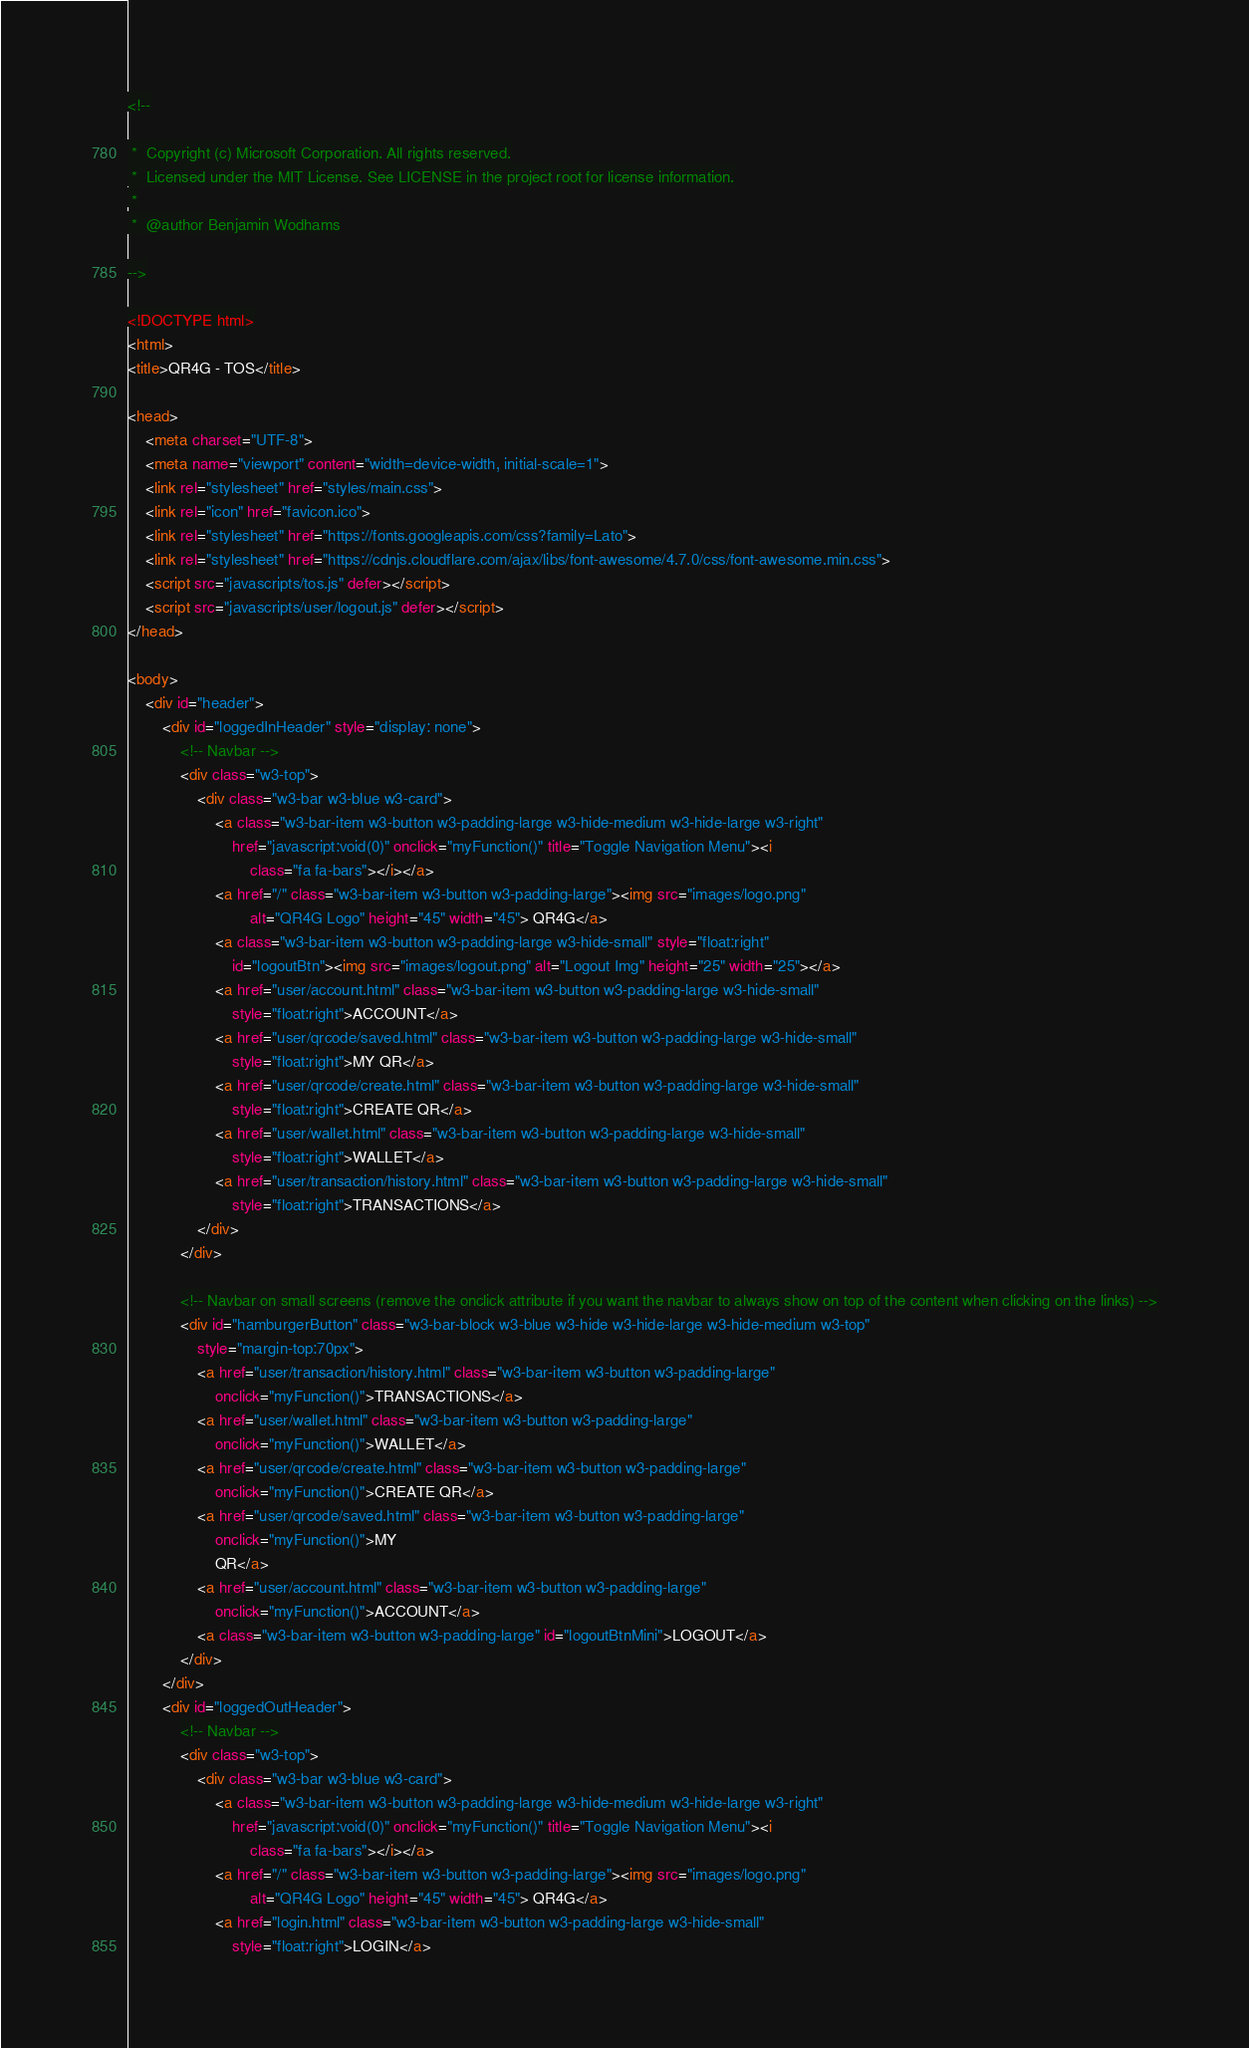Convert code to text. <code><loc_0><loc_0><loc_500><loc_500><_HTML_><!--

 *  Copyright (c) Microsoft Corporation. All rights reserved.
 *  Licensed under the MIT License. See LICENSE in the project root for license information.
 *
 *  @author Benjamin Wodhams

-->

<!DOCTYPE html>
<html>
<title>QR4G - TOS</title>

<head>
    <meta charset="UTF-8">
    <meta name="viewport" content="width=device-width, initial-scale=1">
    <link rel="stylesheet" href="styles/main.css">
    <link rel="icon" href="favicon.ico">
    <link rel="stylesheet" href="https://fonts.googleapis.com/css?family=Lato">
    <link rel="stylesheet" href="https://cdnjs.cloudflare.com/ajax/libs/font-awesome/4.7.0/css/font-awesome.min.css">
    <script src="javascripts/tos.js" defer></script>
    <script src="javascripts/user/logout.js" defer></script>
</head>

<body>
    <div id="header">
        <div id="loggedInHeader" style="display: none">
            <!-- Navbar -->
            <div class="w3-top">
                <div class="w3-bar w3-blue w3-card">
                    <a class="w3-bar-item w3-button w3-padding-large w3-hide-medium w3-hide-large w3-right"
                        href="javascript:void(0)" onclick="myFunction()" title="Toggle Navigation Menu"><i
                            class="fa fa-bars"></i></a>
                    <a href="/" class="w3-bar-item w3-button w3-padding-large"><img src="images/logo.png"
                            alt="QR4G Logo" height="45" width="45"> QR4G</a>
                    <a class="w3-bar-item w3-button w3-padding-large w3-hide-small" style="float:right"
                        id="logoutBtn"><img src="images/logout.png" alt="Logout Img" height="25" width="25"></a>
                    <a href="user/account.html" class="w3-bar-item w3-button w3-padding-large w3-hide-small"
                        style="float:right">ACCOUNT</a>
                    <a href="user/qrcode/saved.html" class="w3-bar-item w3-button w3-padding-large w3-hide-small"
                        style="float:right">MY QR</a>
                    <a href="user/qrcode/create.html" class="w3-bar-item w3-button w3-padding-large w3-hide-small"
                        style="float:right">CREATE QR</a>
                    <a href="user/wallet.html" class="w3-bar-item w3-button w3-padding-large w3-hide-small"
                        style="float:right">WALLET</a>
                    <a href="user/transaction/history.html" class="w3-bar-item w3-button w3-padding-large w3-hide-small"
                        style="float:right">TRANSACTIONS</a>
                </div>
            </div>

            <!-- Navbar on small screens (remove the onclick attribute if you want the navbar to always show on top of the content when clicking on the links) -->
            <div id="hamburgerButton" class="w3-bar-block w3-blue w3-hide w3-hide-large w3-hide-medium w3-top"
                style="margin-top:70px">
                <a href="user/transaction/history.html" class="w3-bar-item w3-button w3-padding-large"
                    onclick="myFunction()">TRANSACTIONS</a>
                <a href="user/wallet.html" class="w3-bar-item w3-button w3-padding-large"
                    onclick="myFunction()">WALLET</a>
                <a href="user/qrcode/create.html" class="w3-bar-item w3-button w3-padding-large"
                    onclick="myFunction()">CREATE QR</a>
                <a href="user/qrcode/saved.html" class="w3-bar-item w3-button w3-padding-large"
                    onclick="myFunction()">MY
                    QR</a>
                <a href="user/account.html" class="w3-bar-item w3-button w3-padding-large"
                    onclick="myFunction()">ACCOUNT</a>
                <a class="w3-bar-item w3-button w3-padding-large" id="logoutBtnMini">LOGOUT</a>
            </div>
        </div>
        <div id="loggedOutHeader">
            <!-- Navbar -->
            <div class="w3-top">
                <div class="w3-bar w3-blue w3-card">
                    <a class="w3-bar-item w3-button w3-padding-large w3-hide-medium w3-hide-large w3-right"
                        href="javascript:void(0)" onclick="myFunction()" title="Toggle Navigation Menu"><i
                            class="fa fa-bars"></i></a>
                    <a href="/" class="w3-bar-item w3-button w3-padding-large"><img src="images/logo.png"
                            alt="QR4G Logo" height="45" width="45"> QR4G</a>
                    <a href="login.html" class="w3-bar-item w3-button w3-padding-large w3-hide-small"
                        style="float:right">LOGIN</a></code> 